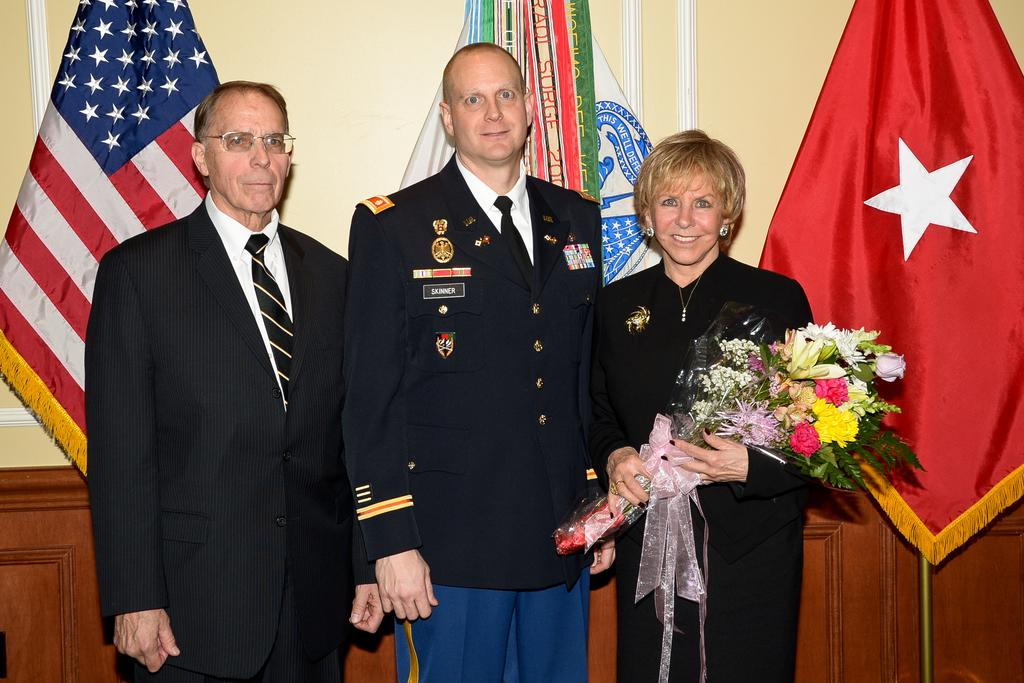How many people are present in the room in the image? There are three people standing in the room in the image. What is the woman holding in the image? The woman is holding a flower bouquet. What can be seen in the background of the image? There are flags and a wall in the background of the image. Where is the ant located in the image? There is no ant present in the image. How many passengers are visible in the image? There is no reference to passengers in the image, as it features people standing in a room. 